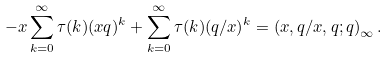Convert formula to latex. <formula><loc_0><loc_0><loc_500><loc_500>- x \sum _ { k = 0 } ^ { \infty } \tau ( k ) ( x q ) ^ { k } + \sum _ { k = 0 } ^ { \infty } \tau ( k ) ( q / x ) ^ { k } = \left ( x , q / x , q ; q \right ) _ { \infty } .</formula> 